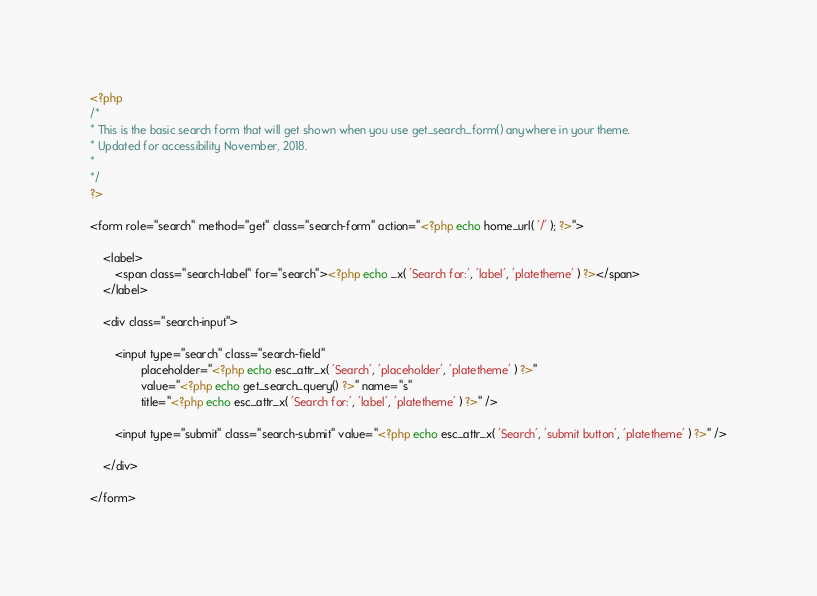Convert code to text. <code><loc_0><loc_0><loc_500><loc_500><_PHP_><?php
/*
* This is the basic search form that will get shown when you use get_search_form() anywhere in your theme.
* Updated for accessibility November, 2018.
*
*/
?>

<form role="search" method="get" class="search-form" action="<?php echo home_url( '/' ); ?>">

    <label>
        <span class="search-label" for="search"><?php echo _x( 'Search for:', 'label', 'platetheme' ) ?></span>
    </label>

    <div class="search-input">

        <input type="search" class="search-field"
                placeholder="<?php echo esc_attr_x( 'Search', 'placeholder', 'platetheme' ) ?>"
                value="<?php echo get_search_query() ?>" name="s"
                title="<?php echo esc_attr_x( 'Search for:', 'label', 'platetheme' ) ?>" />

        <input type="submit" class="search-submit" value="<?php echo esc_attr_x( 'Search', 'submit button', 'platetheme' ) ?>" />

    </div>
    
</form></code> 